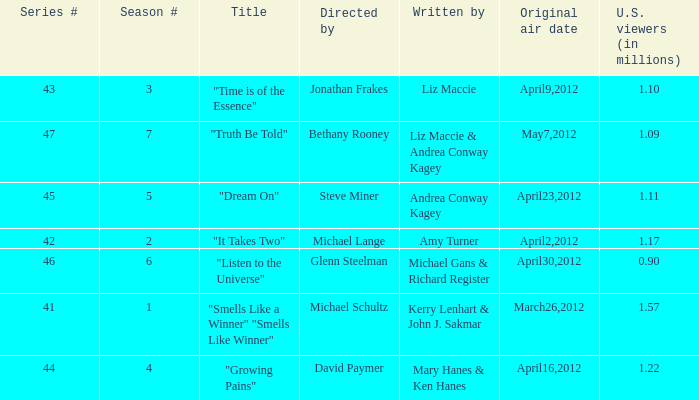What are the titles of the episodes which had 1.10 million U.S. viewers? "Time is of the Essence". 